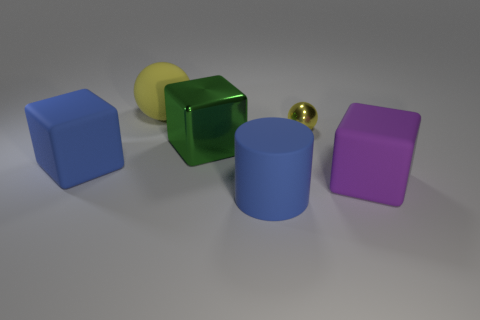Are there more blue things that are on the left side of the blue cube than big matte blocks that are on the right side of the matte ball?
Offer a very short reply. No. Is the tiny ball made of the same material as the sphere to the left of the tiny sphere?
Offer a terse response. No. There is a block that is behind the large blue matte object on the left side of the big rubber cylinder; what number of blue matte blocks are on the right side of it?
Offer a terse response. 0. Does the large yellow rubber thing have the same shape as the large rubber thing in front of the big purple block?
Give a very brief answer. No. The large object that is both behind the blue cylinder and in front of the blue cube is what color?
Make the answer very short. Purple. There is a ball that is left of the big matte object that is in front of the cube that is on the right side of the green block; what is its material?
Provide a short and direct response. Rubber. What is the large purple object made of?
Keep it short and to the point. Rubber. What size is the purple object that is the same shape as the green thing?
Offer a very short reply. Large. Do the tiny metal thing and the matte sphere have the same color?
Give a very brief answer. Yes. How many other objects are the same material as the large ball?
Your answer should be compact. 3. 